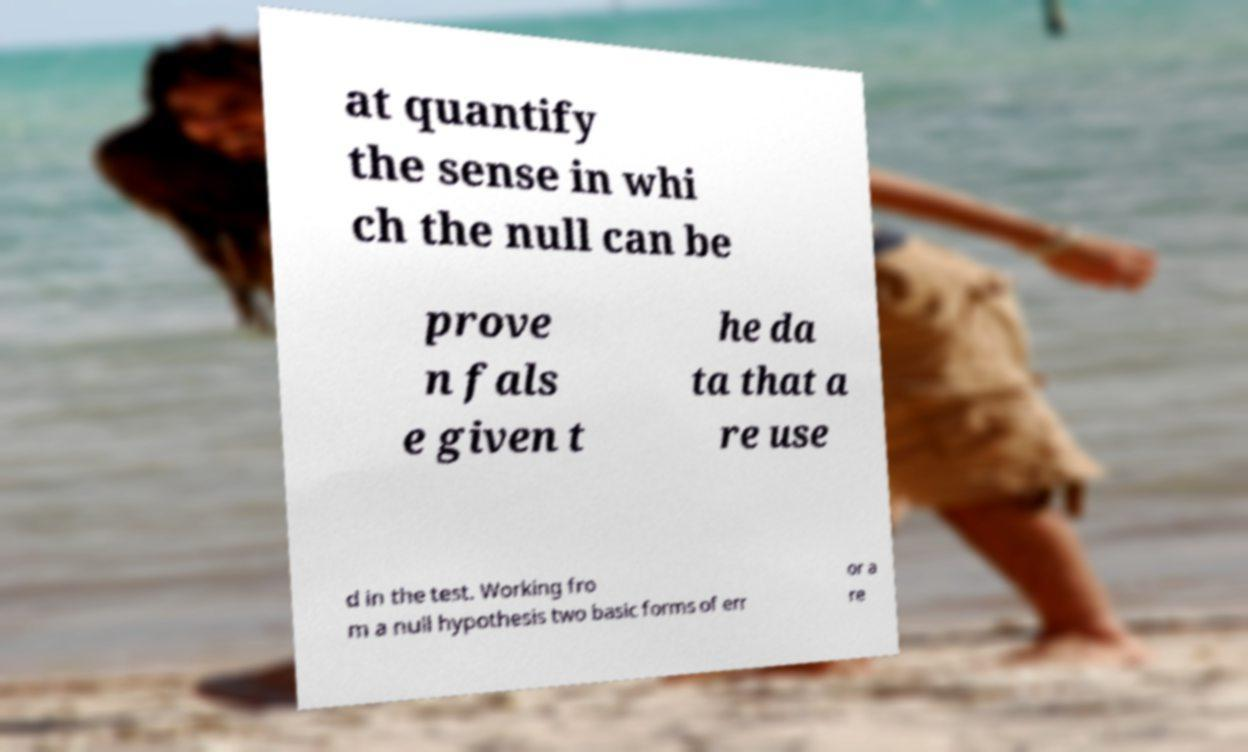For documentation purposes, I need the text within this image transcribed. Could you provide that? at quantify the sense in whi ch the null can be prove n fals e given t he da ta that a re use d in the test. Working fro m a null hypothesis two basic forms of err or a re 